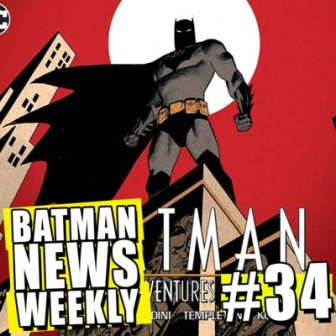Describe the mood and atmosphere created by the colors and composition in this image. The image evokes a mood of intensity and vigilance largely driven by its bold color scheme and dramatic composition. The striking red background instills a sense of urgency and danger, effectively setting the stage for the hero's presence. Batman’s dark and imposing silhouette against this vibrant background accentuates the feeling of nightfall, a time associated with secrecy and suspense. The yellow building beneath Batman, outlined starkly in black, adds a touch of warmth and realism, while also highlighting Batman’s stark contrast with his surroundings. Overall, the combination of these elements conveys a scene that is both intense and thrilling, fitting the narrative style of a Batman comic. 